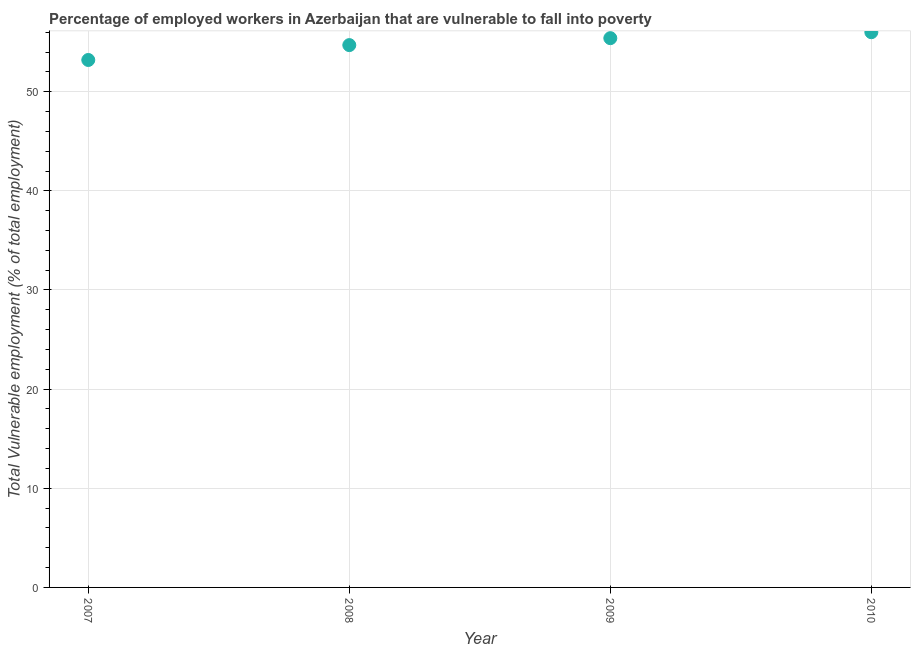Across all years, what is the minimum total vulnerable employment?
Keep it short and to the point. 53.2. In which year was the total vulnerable employment maximum?
Provide a succinct answer. 2010. What is the sum of the total vulnerable employment?
Keep it short and to the point. 219.3. What is the difference between the total vulnerable employment in 2007 and 2009?
Your answer should be compact. -2.2. What is the average total vulnerable employment per year?
Offer a terse response. 54.83. What is the median total vulnerable employment?
Ensure brevity in your answer.  55.05. In how many years, is the total vulnerable employment greater than 30 %?
Offer a very short reply. 4. What is the ratio of the total vulnerable employment in 2007 to that in 2009?
Make the answer very short. 0.96. Is the total vulnerable employment in 2008 less than that in 2009?
Give a very brief answer. Yes. What is the difference between the highest and the second highest total vulnerable employment?
Offer a terse response. 0.6. Is the sum of the total vulnerable employment in 2007 and 2009 greater than the maximum total vulnerable employment across all years?
Offer a terse response. Yes. What is the difference between the highest and the lowest total vulnerable employment?
Give a very brief answer. 2.8. Does the total vulnerable employment monotonically increase over the years?
Your response must be concise. Yes. How many dotlines are there?
Make the answer very short. 1. Are the values on the major ticks of Y-axis written in scientific E-notation?
Give a very brief answer. No. What is the title of the graph?
Your response must be concise. Percentage of employed workers in Azerbaijan that are vulnerable to fall into poverty. What is the label or title of the X-axis?
Provide a short and direct response. Year. What is the label or title of the Y-axis?
Your response must be concise. Total Vulnerable employment (% of total employment). What is the Total Vulnerable employment (% of total employment) in 2007?
Offer a terse response. 53.2. What is the Total Vulnerable employment (% of total employment) in 2008?
Offer a very short reply. 54.7. What is the Total Vulnerable employment (% of total employment) in 2009?
Give a very brief answer. 55.4. What is the difference between the Total Vulnerable employment (% of total employment) in 2007 and 2008?
Provide a succinct answer. -1.5. What is the difference between the Total Vulnerable employment (% of total employment) in 2008 and 2009?
Your answer should be compact. -0.7. What is the ratio of the Total Vulnerable employment (% of total employment) in 2007 to that in 2009?
Ensure brevity in your answer.  0.96. What is the ratio of the Total Vulnerable employment (% of total employment) in 2007 to that in 2010?
Offer a terse response. 0.95. What is the ratio of the Total Vulnerable employment (% of total employment) in 2008 to that in 2009?
Ensure brevity in your answer.  0.99. 